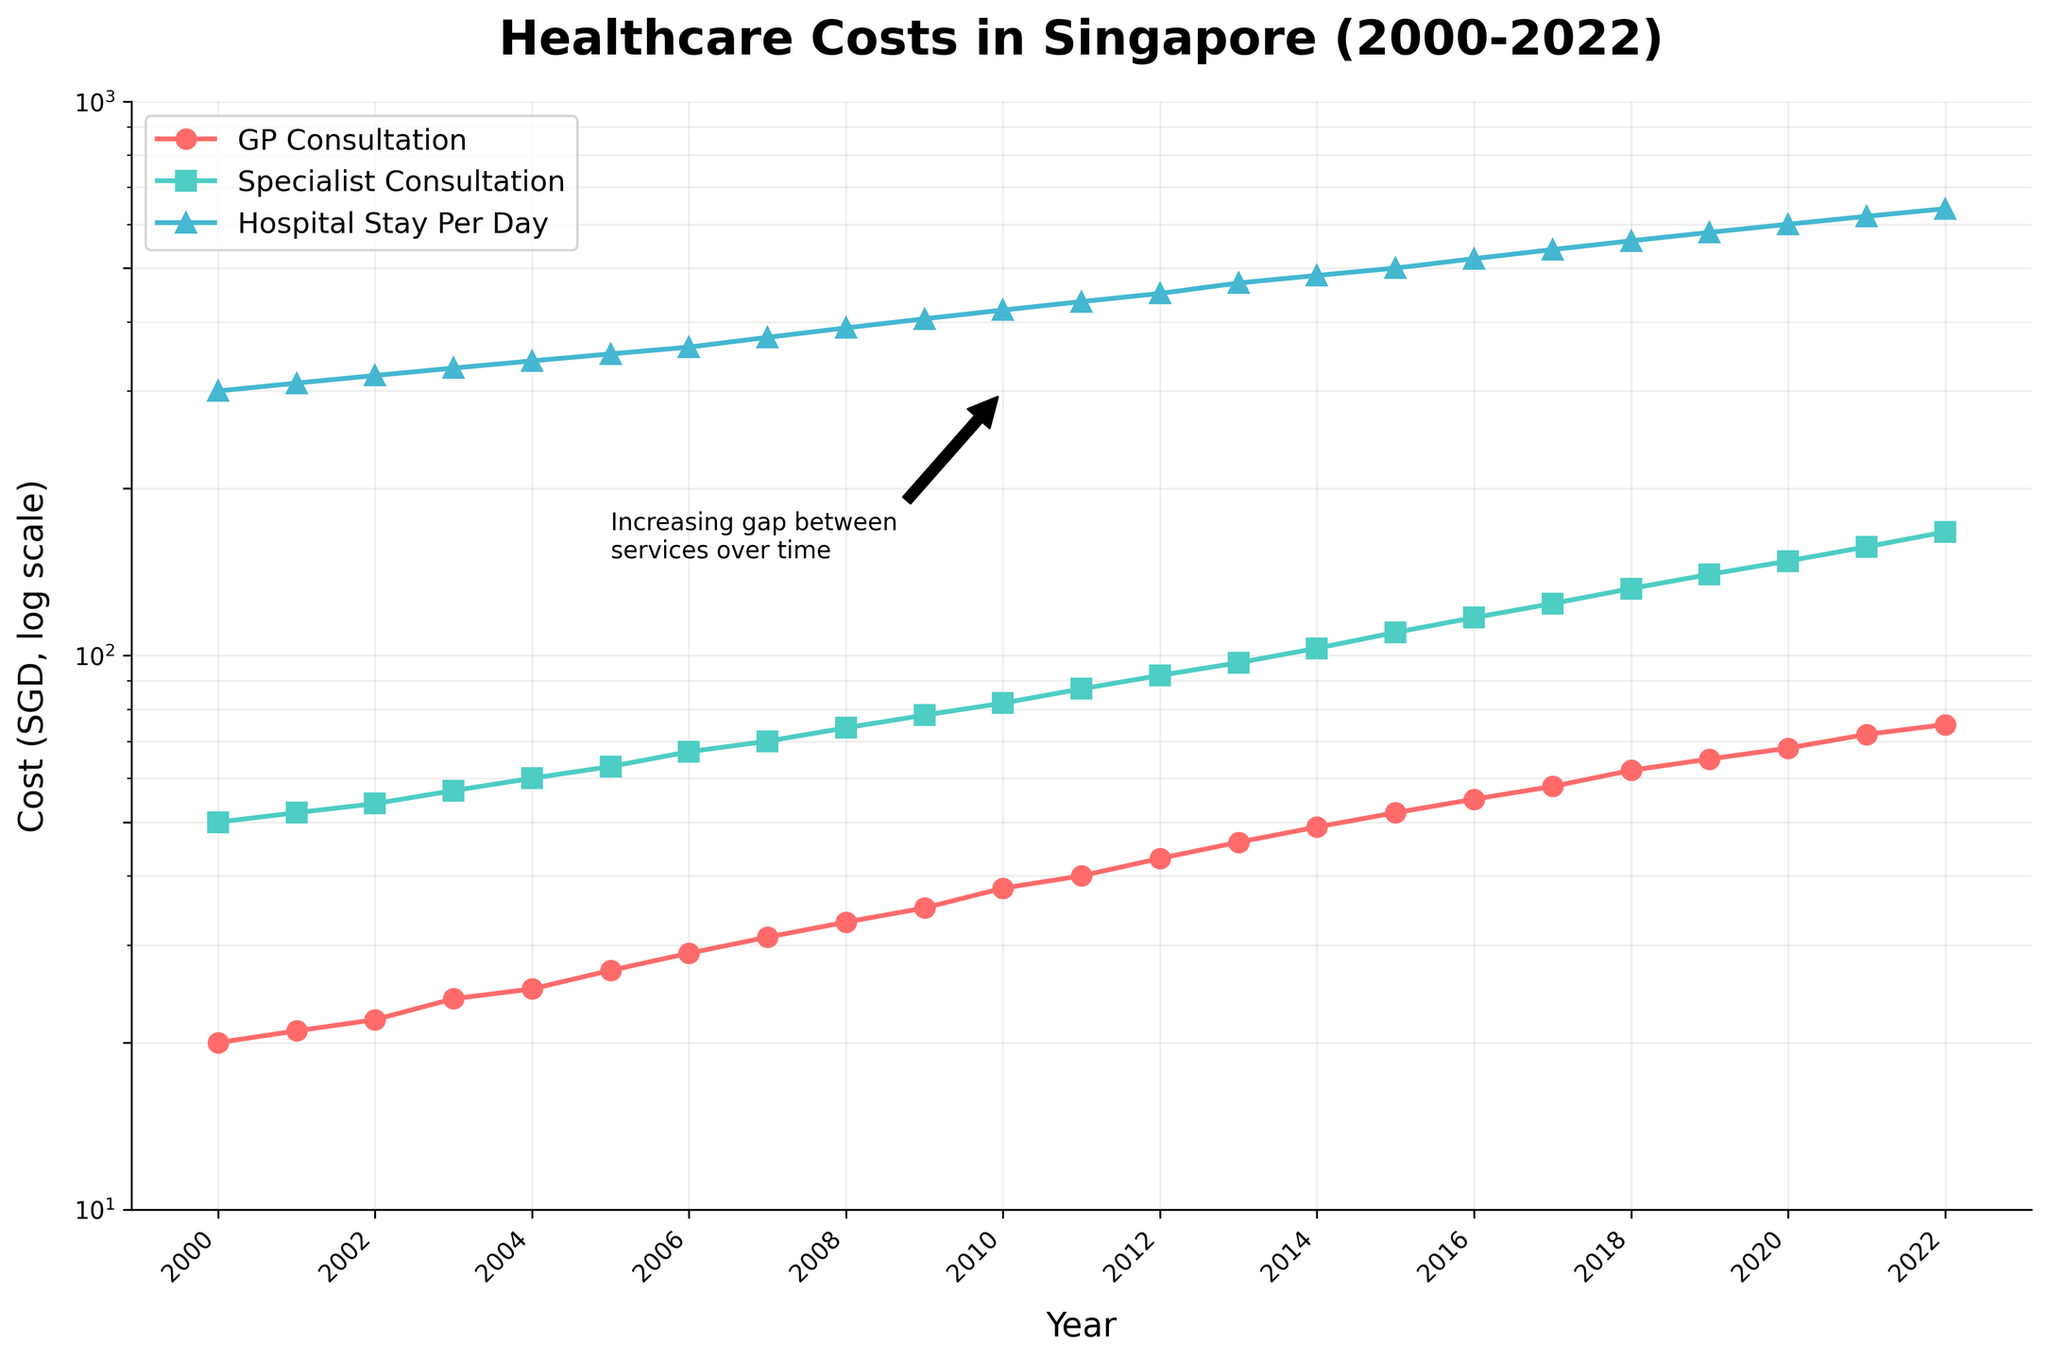Which service had the lowest cost in the year 2000? The plot shows three lines representing different medical services. The line for GP Consultation starts at the lowest position in 2000.
Answer: GP Consultation How did the cost of Hospital Stays change from 2000 to 2022? The cost of Hospital Stays increased from 300 SGD per day in 2000 to 640 SGD per day in 2022, as indicated by the upward trend of the Hospital Stay line.
Answer: Increased from 300 to 640 SGD By what factor did the cost of GP Consultation increase between 2000 and 2022? The cost of GP Consultation in 2000 was 20 SGD, and it increased to 75 SGD in 2022. The factor can be calculated as 75 / 20.
Answer: 3.75 Which year saw the steepest increase in Specialist Consultation costs compared to the previous year? By visually checking the steepness of the Specialist Consultation line year over year, the largest jump seems to be between 2020 and 2021, from 148 to 157 SGD.
Answer: 2021 Which service showed the most consistent growth over time? By comparing the smoothness of the lines, the GP Consultation line appears to be the most consistently smooth and steadily increasing.
Answer: GP Consultation What is the approximate cost of Specialist Consultation in 2015? The Specialist Consultation line can be traced to the year 2015, where it intersects at around 110 SGD.
Answer: 110 SGD How much did the cost of a Hospital Stay increase between 2010 and 2020? The cost of Hospital Stay in 2010 was 420 SGD and increased to 600 SGD in 2020. The increase is 600 - 420.
Answer: 180 SGD Comparing 2005 and 2010, which service saw the highest percentage increase in costs? GP Consultation increased from 27 to 38 SGD, Specialist Consultation from 63 to 82 SGD, and Hospital Stay from 350 to 420 SGD. Calculating the percentage increase for each:
GP (38-27)/27 ≈ 40.7%,
Specialist (82-63)/63 ≈ 30.2%,
Hospital (420-350)/350 ≈ 20%
Answer: GP Consultation How does the log scale affect the appearance of the trends in healthcare costs? The log scale compresses higher values and spreads lower values, making it easier to see percentage changes over time and smoothing out exponential growth patterns.
Answer: Compresses higher values What is the annotation in the plot referring to? The annotation highlights the increasing gap between the costs of different services, which is evident from the diverging slopes of the three lines after 2010.
Answer: Increasing gap between services over time 